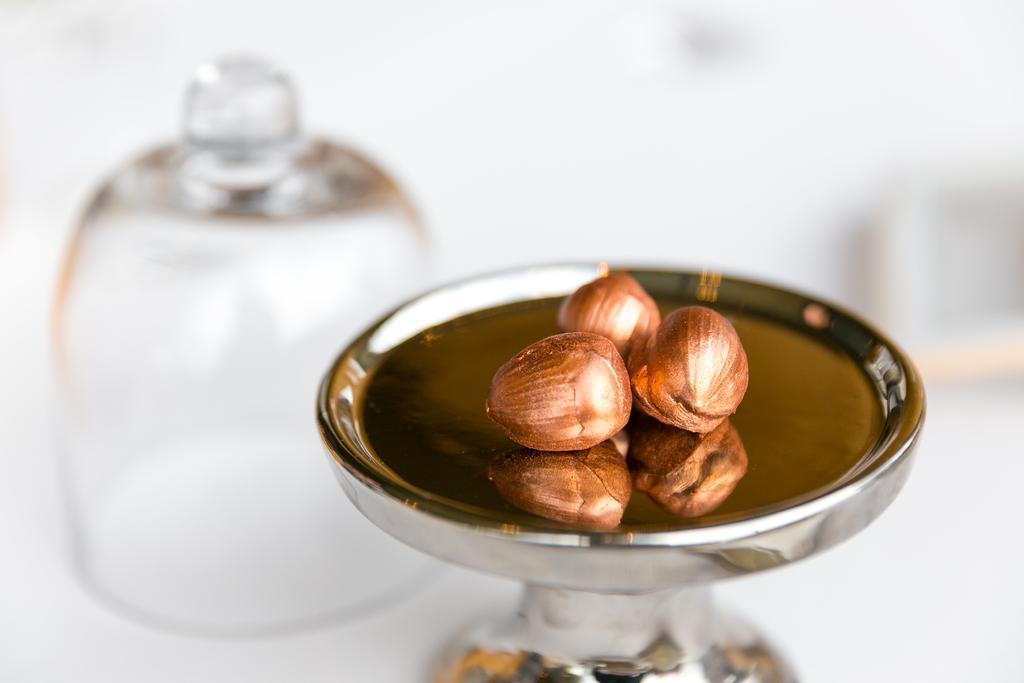Please provide a concise description of this image. In the foreground of this picture we can see an object containing some items which seems to be the food items. On the left there is an object which seems to be the glass jar. The background of the image is blurry. 